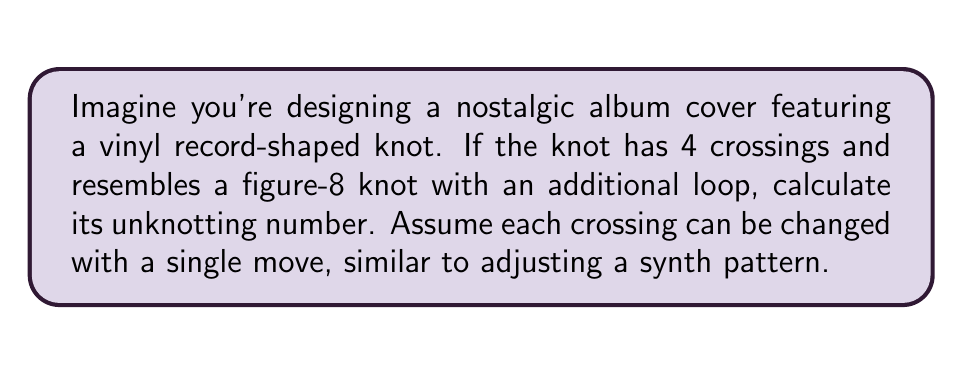Show me your answer to this math problem. To determine the unknotting number of this vinyl record-shaped knot, we need to follow these steps:

1. Identify the knot type:
   The described knot resembles a figure-8 knot with an additional loop. The figure-8 knot has 4 crossings, and the additional loop adds complexity.

2. Consider the properties of the figure-8 knot:
   The figure-8 knot has an unknotting number of 1, meaning it can be transformed into an unknot with a single crossing change.

3. Analyze the additional loop:
   The extra loop likely introduces at least one more essential crossing that needs to be resolved.

4. Calculate the minimum number of crossing changes:
   a) At least one crossing change is needed for the figure-8 part: 1
   b) At least one additional crossing change is needed for the extra loop: 1
   
   Total minimum crossing changes: 1 + 1 = 2

5. Verify the result:
   The unknotting number cannot be less than 2 because:
   a) The figure-8 knot alone requires 1 change
   b) The additional loop must be resolved, requiring at least 1 more change

Therefore, the unknotting number of this vinyl record-shaped knot is 2.

This can be expressed mathematically as:

$$u(K) = 2$$

Where $u(K)$ represents the unknotting number of the knot $K$.
Answer: 2 